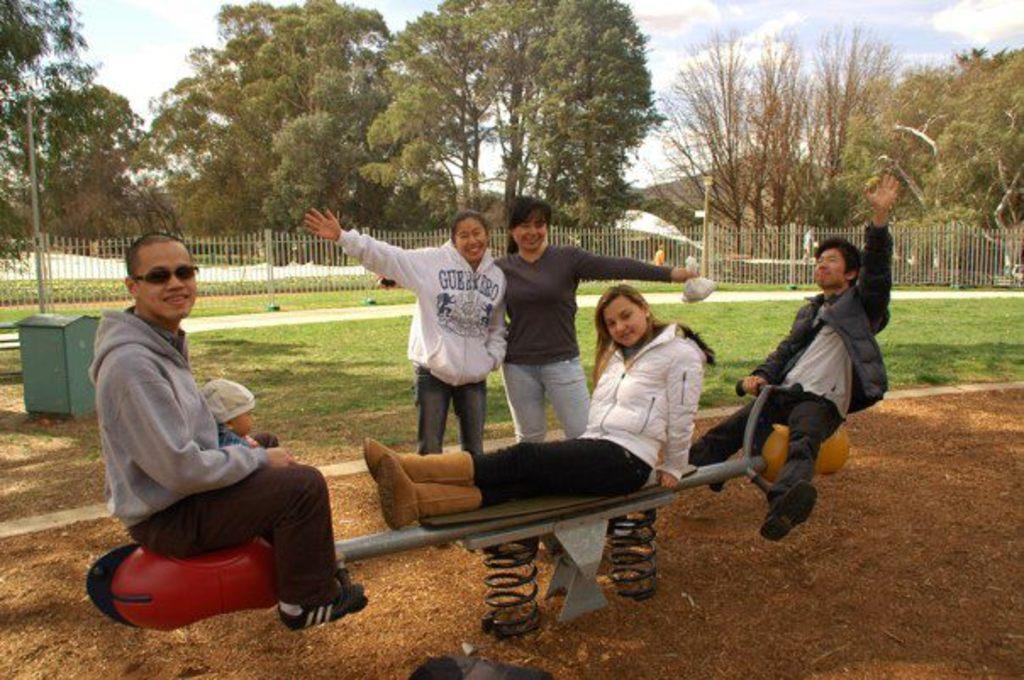Can you describe this image briefly? Here we can see a kid and three persons are sitting on the seesaw. There are two persons standing on the ground. This is grass. Here we can see a fence, poles, and trees. In the background there is sky. 